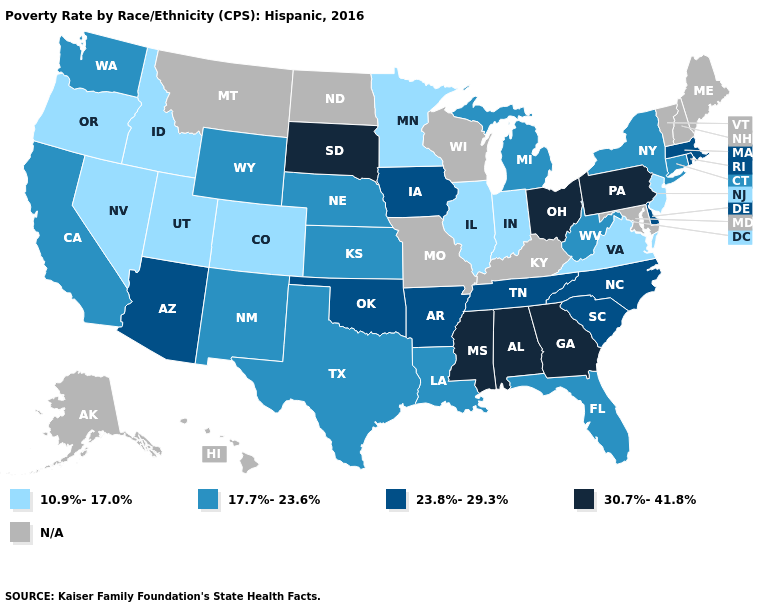Name the states that have a value in the range 23.8%-29.3%?
Quick response, please. Arizona, Arkansas, Delaware, Iowa, Massachusetts, North Carolina, Oklahoma, Rhode Island, South Carolina, Tennessee. What is the value of Alabama?
Concise answer only. 30.7%-41.8%. Name the states that have a value in the range 30.7%-41.8%?
Concise answer only. Alabama, Georgia, Mississippi, Ohio, Pennsylvania, South Dakota. What is the value of Kentucky?
Answer briefly. N/A. Does Pennsylvania have the highest value in the USA?
Answer briefly. Yes. What is the highest value in states that border Arkansas?
Write a very short answer. 30.7%-41.8%. Name the states that have a value in the range 17.7%-23.6%?
Be succinct. California, Connecticut, Florida, Kansas, Louisiana, Michigan, Nebraska, New Mexico, New York, Texas, Washington, West Virginia, Wyoming. Which states have the highest value in the USA?
Short answer required. Alabama, Georgia, Mississippi, Ohio, Pennsylvania, South Dakota. Name the states that have a value in the range N/A?
Be succinct. Alaska, Hawaii, Kentucky, Maine, Maryland, Missouri, Montana, New Hampshire, North Dakota, Vermont, Wisconsin. What is the value of Kansas?
Concise answer only. 17.7%-23.6%. What is the value of North Dakota?
Write a very short answer. N/A. Which states hav the highest value in the South?
Be succinct. Alabama, Georgia, Mississippi. 